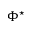<formula> <loc_0><loc_0><loc_500><loc_500>\Phi ^ { ^ { * } }</formula> 